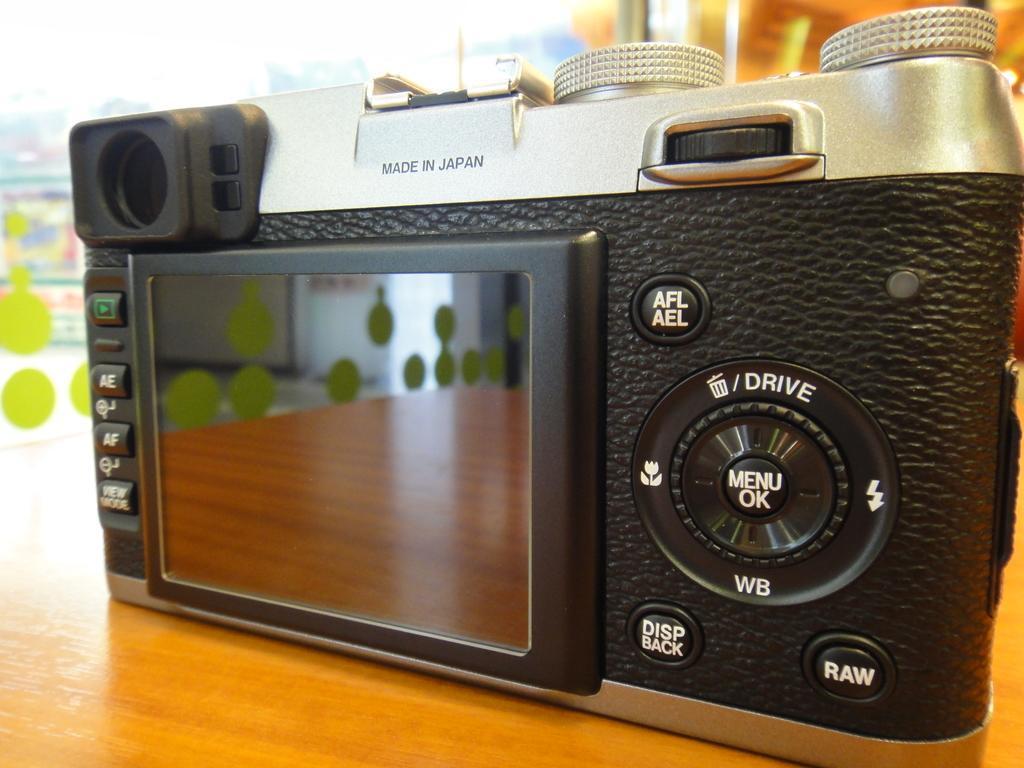How would you summarize this image in a sentence or two? This image is taken indoors. At the bottom of the image there is a table with a camera on it. In this image the background is a little blurred. 